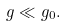Convert formula to latex. <formula><loc_0><loc_0><loc_500><loc_500>g \ll g _ { 0 } .</formula> 